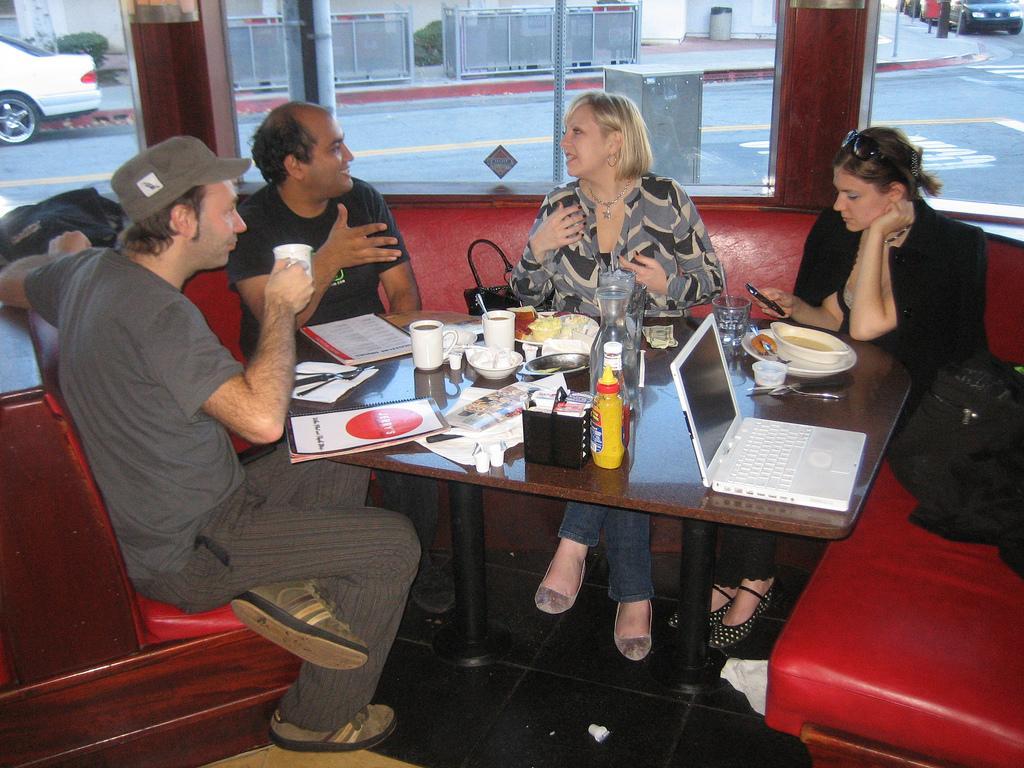How would you summarize this image in a sentence or two? The picture is taken inside the room where four people are sitting on a sofa in front of a table. On the table there is a laptop,sauce,bottles,cups and plates are there and some books and papers also there. Coming to the right corner of the picture there are bags on the sofa and behind the people there is a mirror window and outside the room there is a road and some vehicles on the road, some plants also there and one dustbin. Coming to the right corner of the picture the woman is dressed in black and holding a phone and coming to the left corner of the picture the person is wearing a cap and holding a cup. 